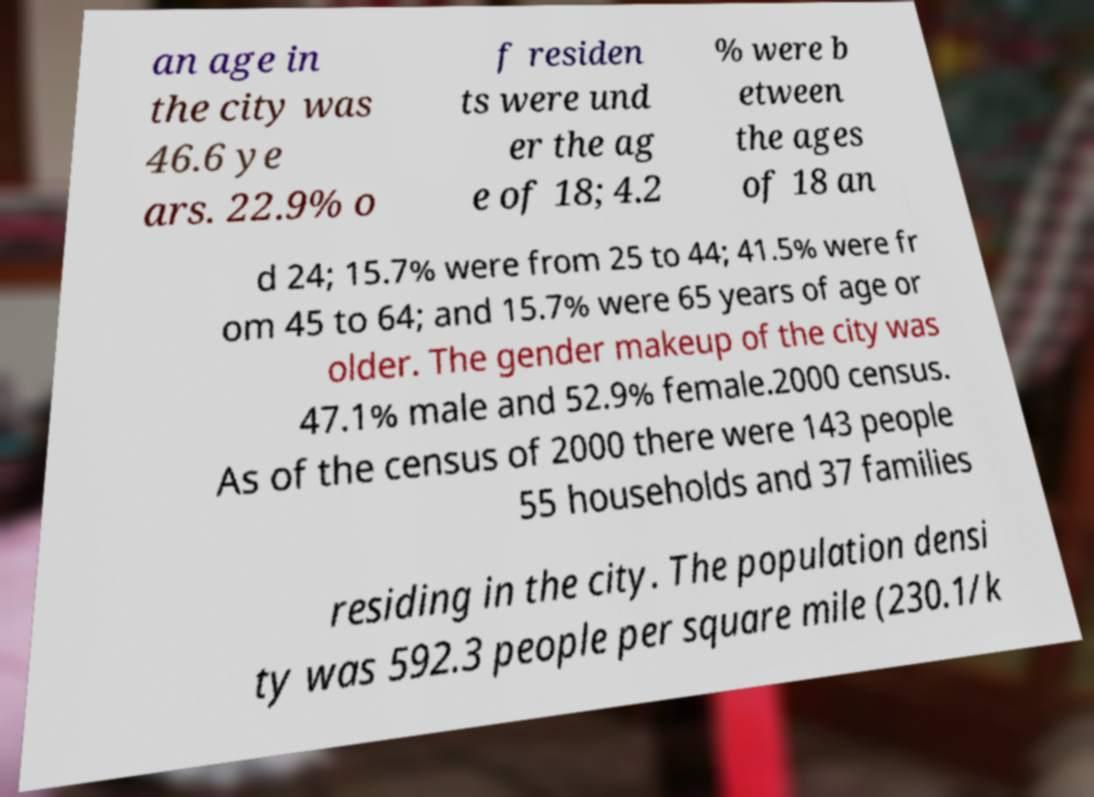I need the written content from this picture converted into text. Can you do that? an age in the city was 46.6 ye ars. 22.9% o f residen ts were und er the ag e of 18; 4.2 % were b etween the ages of 18 an d 24; 15.7% were from 25 to 44; 41.5% were fr om 45 to 64; and 15.7% were 65 years of age or older. The gender makeup of the city was 47.1% male and 52.9% female.2000 census. As of the census of 2000 there were 143 people 55 households and 37 families residing in the city. The population densi ty was 592.3 people per square mile (230.1/k 